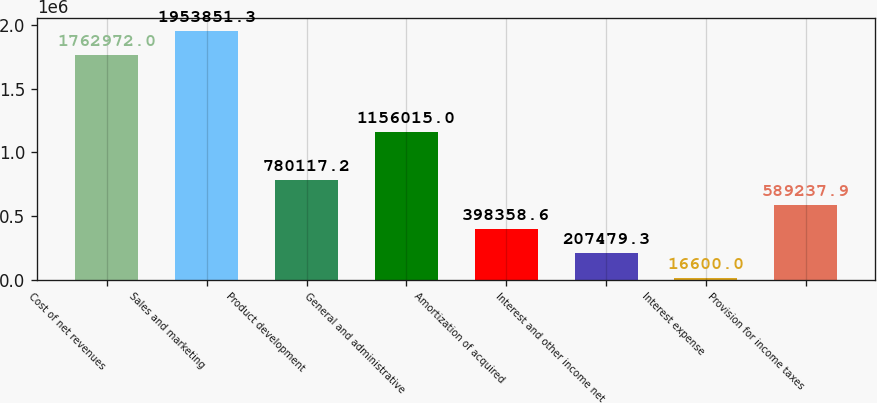Convert chart to OTSL. <chart><loc_0><loc_0><loc_500><loc_500><bar_chart><fcel>Cost of net revenues<fcel>Sales and marketing<fcel>Product development<fcel>General and administrative<fcel>Amortization of acquired<fcel>Interest and other income net<fcel>Interest expense<fcel>Provision for income taxes<nl><fcel>1.76297e+06<fcel>1.95385e+06<fcel>780117<fcel>1.15602e+06<fcel>398359<fcel>207479<fcel>16600<fcel>589238<nl></chart> 